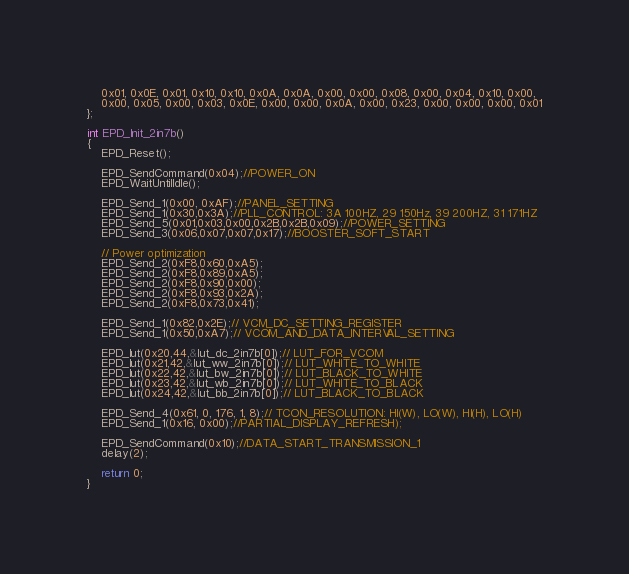Convert code to text. <code><loc_0><loc_0><loc_500><loc_500><_C_>    0x01, 0x0E, 0x01, 0x10, 0x10, 0x0A, 0x0A, 0x00, 0x00, 0x08, 0x00, 0x04, 0x10, 0x00, 
    0x00, 0x05, 0x00, 0x03, 0x0E, 0x00, 0x00, 0x0A, 0x00, 0x23, 0x00, 0x00, 0x00, 0x01
};

int EPD_Init_2in7b() 
{
    EPD_Reset();

    EPD_SendCommand(0x04);//POWER_ON
    EPD_WaitUntilIdle();

    EPD_Send_1(0x00, 0xAF);//PANEL_SETTING
    EPD_Send_1(0x30,0x3A);//PLL_CONTROL: 3A 100HZ, 29 150Hz, 39 200HZ, 31 171HZ
    EPD_Send_5(0x01,0x03,0x00,0x2B,0x2B,0x09);//POWER_SETTING    
    EPD_Send_3(0x06,0x07,0x07,0x17);//BOOSTER_SOFT_START

    // Power optimization
    EPD_Send_2(0xF8,0x60,0xA5);
    EPD_Send_2(0xF8,0x89,0xA5);
    EPD_Send_2(0xF8,0x90,0x00);
    EPD_Send_2(0xF8,0x93,0x2A);
    EPD_Send_2(0xF8,0x73,0x41);

    EPD_Send_1(0x82,0x2E);// VCM_DC_SETTING_REGISTER
    EPD_Send_1(0x50,0xA7);// VCOM_AND_DATA_INTERVAL_SETTING
    
    EPD_lut(0x20,44,&lut_dc_2in7b[0]);// LUT_FOR_VCOM
    EPD_lut(0x21,42,&lut_ww_2in7b[0]);// LUT_WHITE_TO_WHITE   
    EPD_lut(0x22,42,&lut_bw_2in7b[0]);// LUT_BLACK_TO_WHITE
    EPD_lut(0x23,42,&lut_wb_2in7b[0]);// LUT_WHITE_TO_BLACK
    EPD_lut(0x24,42,&lut_bb_2in7b[0]);// LUT_BLACK_TO_BLACK

    EPD_Send_4(0x61, 0, 176, 1, 8);// TCON_RESOLUTION: HI(W), LO(W), HI(H), LO(H)
    EPD_Send_1(0x16, 0x00);//PARTIAL_DISPLAY_REFRESH); 

    EPD_SendCommand(0x10);//DATA_START_TRANSMISSION_1
    delay(2);
   
    return 0;
}
</code> 